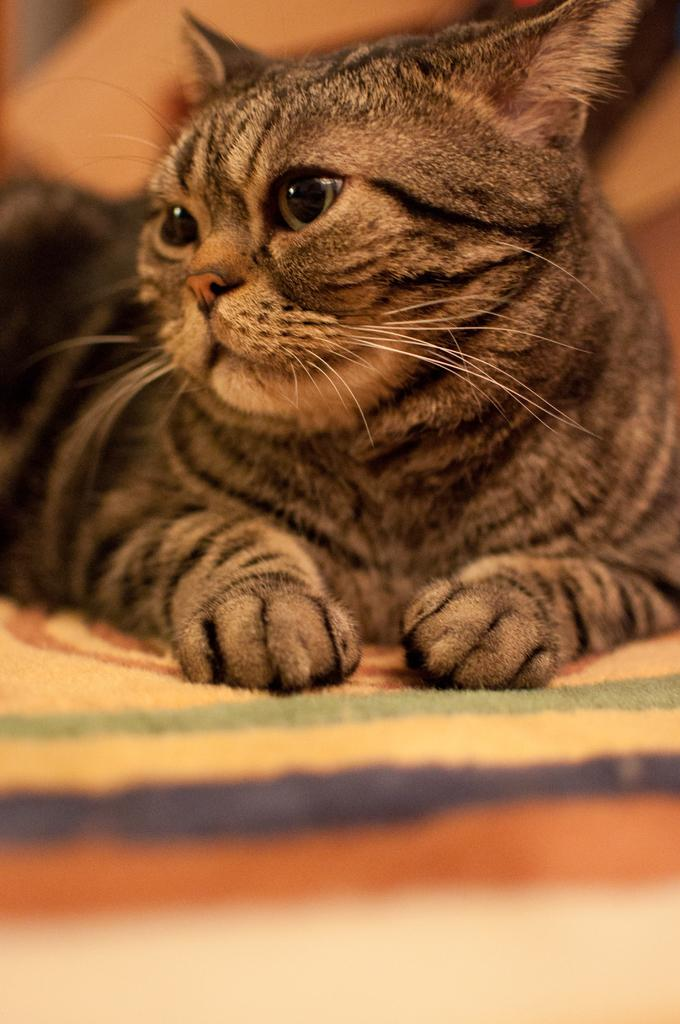What type of animal is present in the image? There is a cat in the image. What type of weather is depicted in the image? There is no weather depicted in the image, as it only features a cat. How many kittens are present in the image? There are no kittens present in the image, only a single cat. 